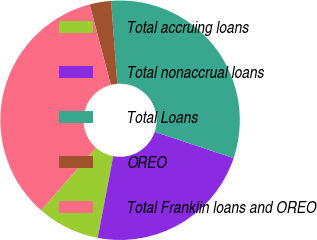Convert chart. <chart><loc_0><loc_0><loc_500><loc_500><pie_chart><fcel>Total accruing loans<fcel>Total nonaccrual loans<fcel>Total Loans<fcel>OREO<fcel>Total Franklin loans and OREO<nl><fcel>8.46%<fcel>22.87%<fcel>31.32%<fcel>2.89%<fcel>34.46%<nl></chart> 